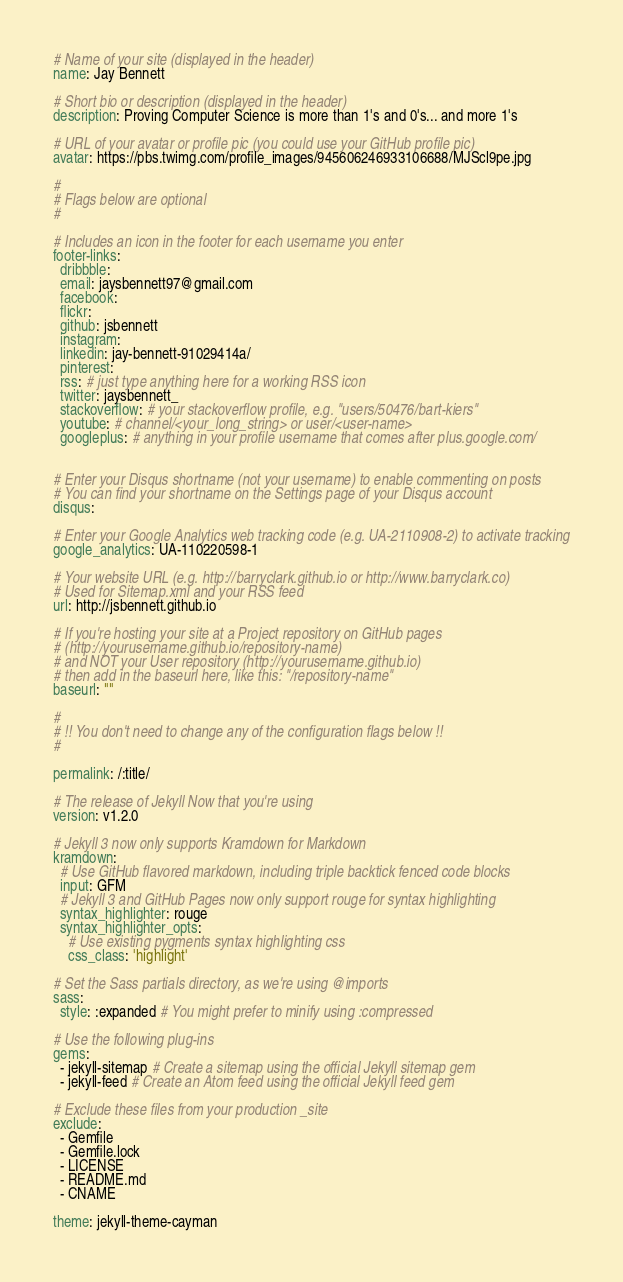Convert code to text. <code><loc_0><loc_0><loc_500><loc_500><_YAML_>
# Name of your site (displayed in the header)
name: Jay Bennett

# Short bio or description (displayed in the header)
description: Proving Computer Science is more than 1's and 0's... and more 1's

# URL of your avatar or profile pic (you could use your GitHub profile pic)
avatar: https://pbs.twimg.com/profile_images/945606246933106688/MJScl9pe.jpg

#
# Flags below are optional
#

# Includes an icon in the footer for each username you enter
footer-links:
  dribbble:
  email: jaysbennett97@gmail.com
  facebook:
  flickr:
  github: jsbennett
  instagram:
  linkedin: jay-bennett-91029414a/
  pinterest:
  rss: # just type anything here for a working RSS icon
  twitter: jaysbennett_
  stackoverflow: # your stackoverflow profile, e.g. "users/50476/bart-kiers"
  youtube: # channel/<your_long_string> or user/<user-name>
  googleplus: # anything in your profile username that comes after plus.google.com/


# Enter your Disqus shortname (not your username) to enable commenting on posts
# You can find your shortname on the Settings page of your Disqus account
disqus:

# Enter your Google Analytics web tracking code (e.g. UA-2110908-2) to activate tracking
google_analytics: UA-110220598-1

# Your website URL (e.g. http://barryclark.github.io or http://www.barryclark.co)
# Used for Sitemap.xml and your RSS feed
url: http://jsbennett.github.io

# If you're hosting your site at a Project repository on GitHub pages
# (http://yourusername.github.io/repository-name)
# and NOT your User repository (http://yourusername.github.io)
# then add in the baseurl here, like this: "/repository-name"
baseurl: ""

#
# !! You don't need to change any of the configuration flags below !!
#

permalink: /:title/

# The release of Jekyll Now that you're using
version: v1.2.0

# Jekyll 3 now only supports Kramdown for Markdown
kramdown:
  # Use GitHub flavored markdown, including triple backtick fenced code blocks
  input: GFM
  # Jekyll 3 and GitHub Pages now only support rouge for syntax highlighting
  syntax_highlighter: rouge
  syntax_highlighter_opts:
    # Use existing pygments syntax highlighting css
    css_class: 'highlight'

# Set the Sass partials directory, as we're using @imports
sass:
  style: :expanded # You might prefer to minify using :compressed

# Use the following plug-ins
gems:
  - jekyll-sitemap # Create a sitemap using the official Jekyll sitemap gem
  - jekyll-feed # Create an Atom feed using the official Jekyll feed gem

# Exclude these files from your production _site
exclude:
  - Gemfile
  - Gemfile.lock
  - LICENSE
  - README.md
  - CNAME

theme: jekyll-theme-cayman
</code> 